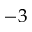<formula> <loc_0><loc_0><loc_500><loc_500>- 3</formula> 